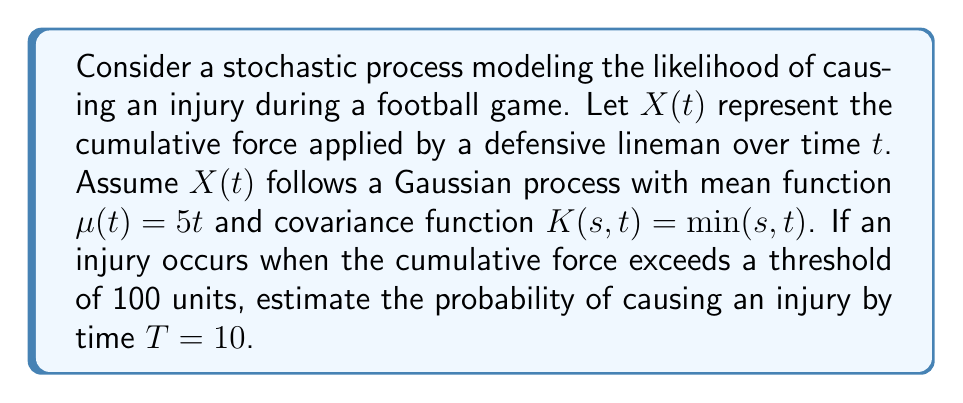Teach me how to tackle this problem. To solve this problem, we'll use concepts from functional analysis and stochastic processes:

1) First, we need to understand that $X(T)$ is normally distributed, as it's a Gaussian process at a fixed time $T$.

2) The mean of $X(T)$ is given by $\mu(T) = 5T = 5 \cdot 10 = 50$.

3) The variance of $X(T)$ is $K(T,T) = \min(T,T) = T = 10$.

4) We want to find $P(X(T) > 100)$, which is equivalent to finding $1 - P(X(T) \leq 100)$.

5) To standardize this, we can use the Z-score formula:

   $$Z = \frac{X - \mu}{\sigma} = \frac{100 - 50}{\sqrt{10}} = \frac{50}{\sqrt{10}} \approx 15.81$$

6) Now, we need to find $1 - P(Z \leq 15.81)$.

7) Using a standard normal distribution table or calculator, we find:

   $P(Z \leq 15.81) \approx 1$

8) Therefore, $P(X(T) > 100) = 1 - P(Z \leq 15.81) \approx 1 - 1 = 0$

This means the probability of causing an injury by time $T=10$ is effectively 0, or extremely close to 0.
Answer: The probability of causing an injury by time $T=10$ is approximately 0. 